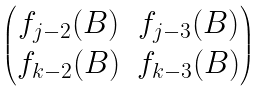Convert formula to latex. <formula><loc_0><loc_0><loc_500><loc_500>\begin{pmatrix} f _ { j - 2 } ( B ) & f _ { j - 3 } ( B ) \\ f _ { k - 2 } ( B ) & f _ { k - 3 } ( B ) \end{pmatrix}</formula> 